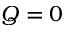<formula> <loc_0><loc_0><loc_500><loc_500>Q = 0</formula> 